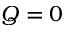<formula> <loc_0><loc_0><loc_500><loc_500>Q = 0</formula> 